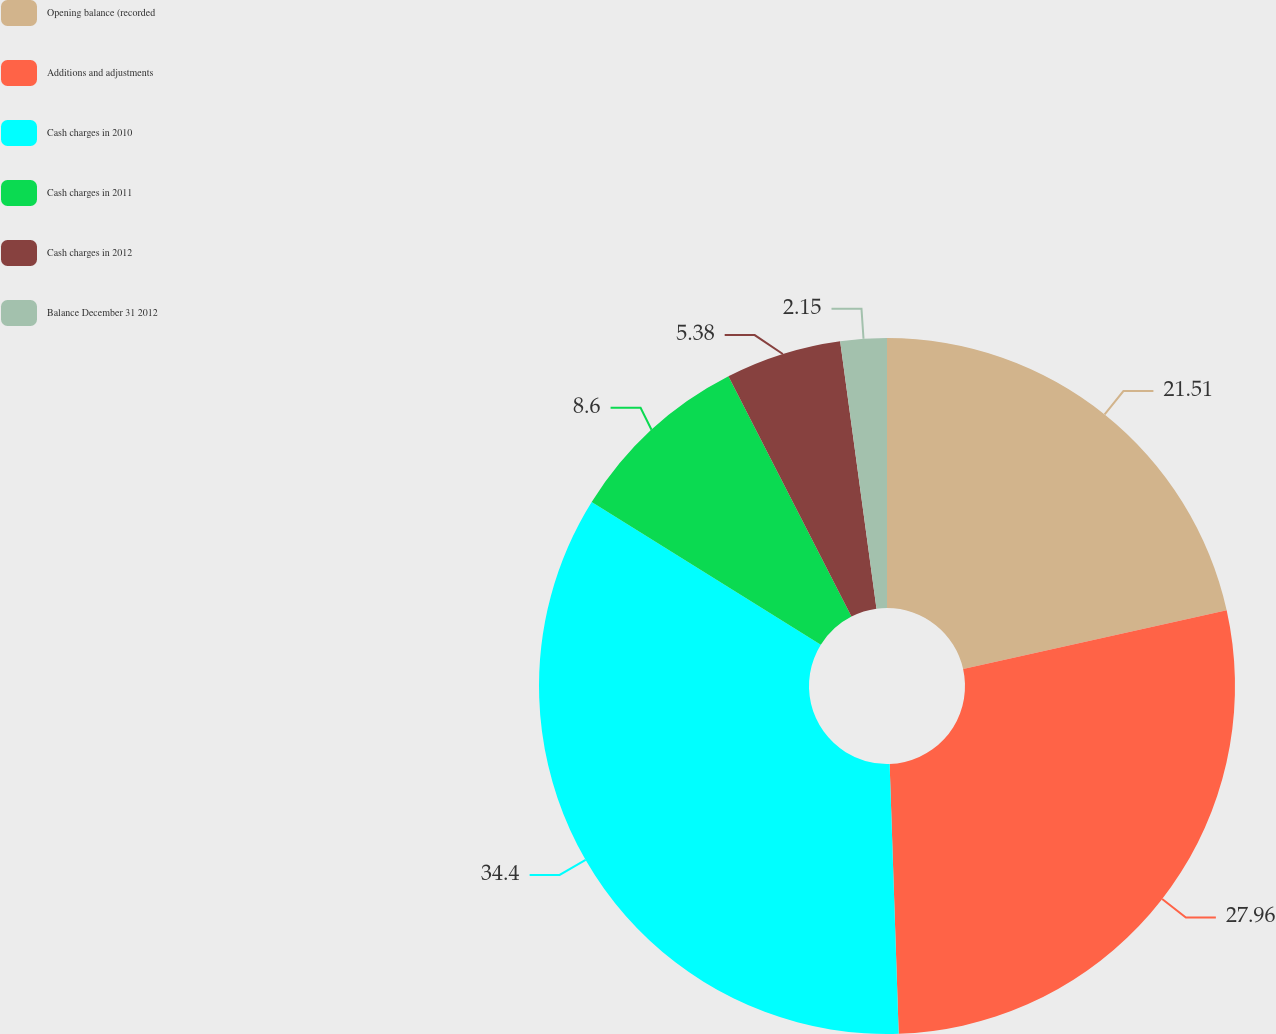Convert chart to OTSL. <chart><loc_0><loc_0><loc_500><loc_500><pie_chart><fcel>Opening balance (recorded<fcel>Additions and adjustments<fcel>Cash charges in 2010<fcel>Cash charges in 2011<fcel>Cash charges in 2012<fcel>Balance December 31 2012<nl><fcel>21.51%<fcel>27.96%<fcel>34.41%<fcel>8.6%<fcel>5.38%<fcel>2.15%<nl></chart> 